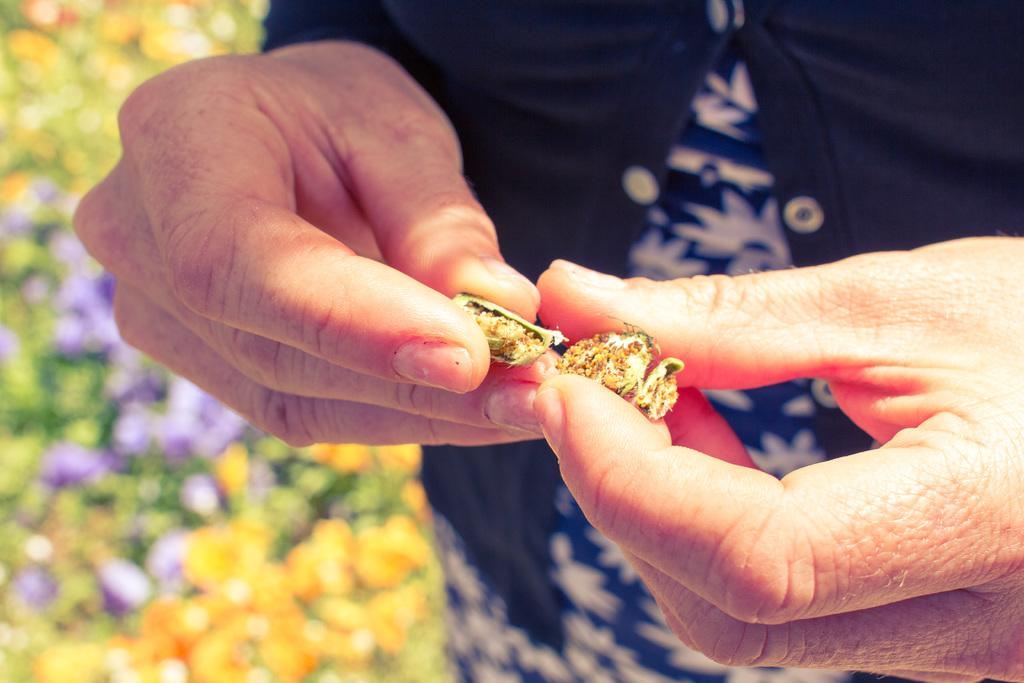What is present in the image? There is a person in the image. What is the person holding? The person is holding something. What type of vegetation can be seen in the image? There are plants and flowers in the image. What type of effect does the cloud have on the canvas in the image? There is no canvas or cloud present in the image. 